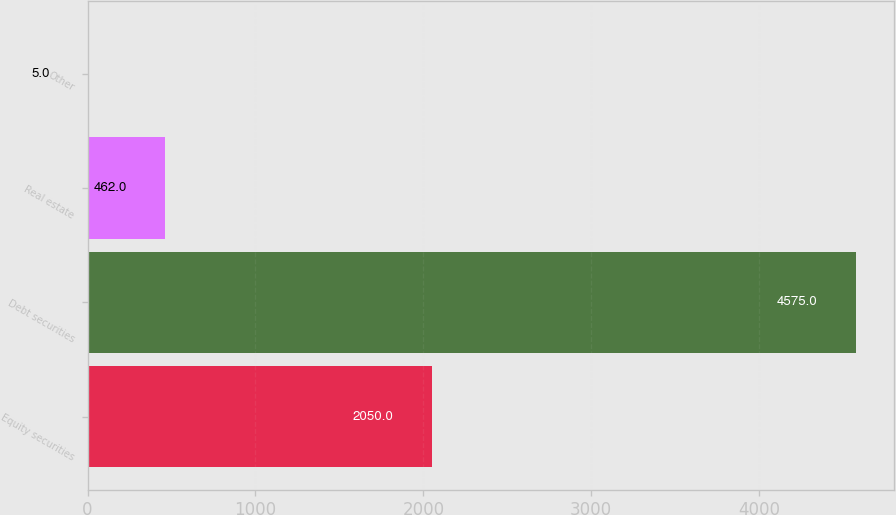Convert chart. <chart><loc_0><loc_0><loc_500><loc_500><bar_chart><fcel>Equity securities<fcel>Debt securities<fcel>Real estate<fcel>Other<nl><fcel>2050<fcel>4575<fcel>462<fcel>5<nl></chart> 